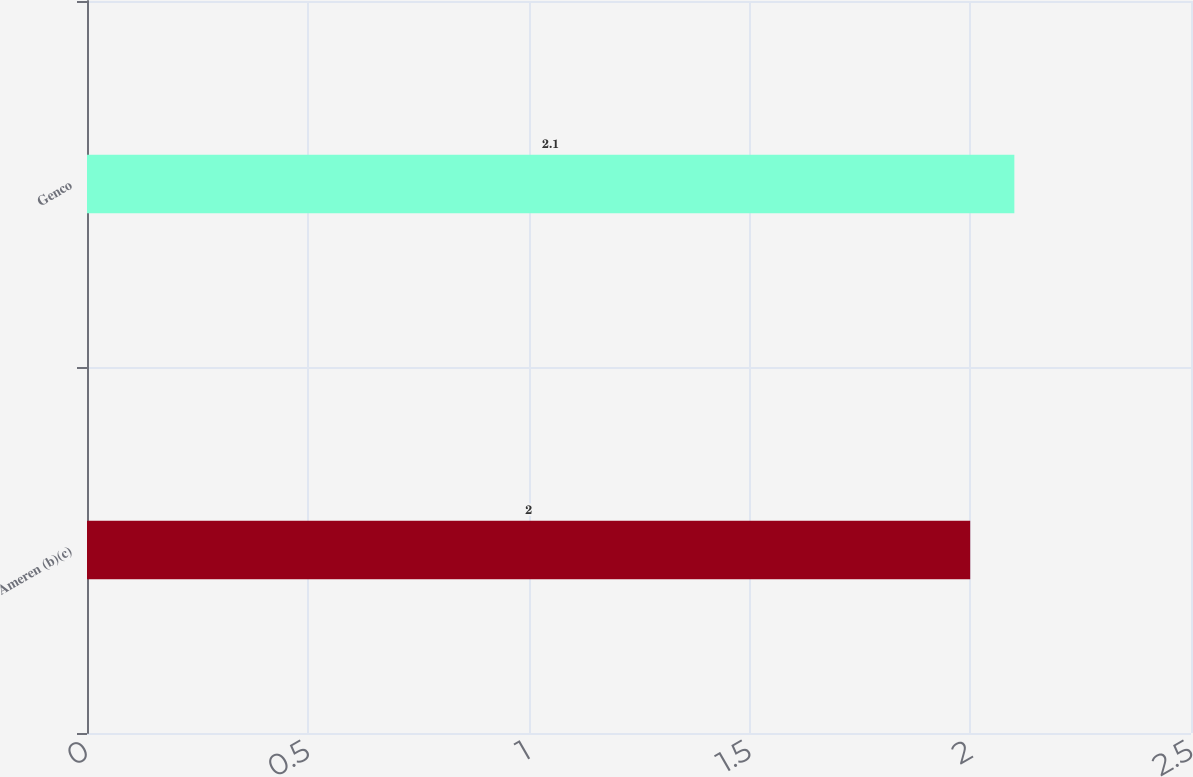Convert chart. <chart><loc_0><loc_0><loc_500><loc_500><bar_chart><fcel>Ameren (b)(c)<fcel>Genco<nl><fcel>2<fcel>2.1<nl></chart> 